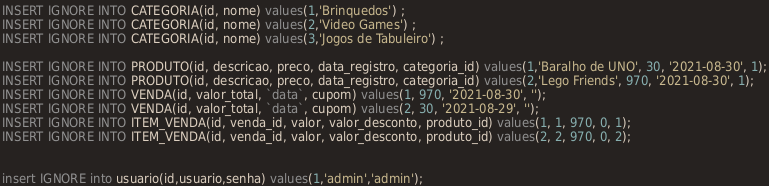<code> <loc_0><loc_0><loc_500><loc_500><_SQL_>INSERT IGNORE INTO CATEGORIA(id, nome) values(1,'Brinquedos') ;
INSERT IGNORE INTO CATEGORIA(id, nome) values(2,'Video Games') ;
INSERT IGNORE INTO CATEGORIA(id, nome) values(3,'Jogos de Tabuleiro') ;

INSERT IGNORE INTO PRODUTO(id, descricao, preco, data_registro, categoria_id) values(1,'Baralho de UNO', 30, '2021-08-30', 1);
INSERT IGNORE INTO PRODUTO(id, descricao, preco, data_registro, categoria_id) values(2,'Lego Friends', 970, '2021-08-30', 1);
INSERT IGNORE INTO VENDA(id, valor_total, `data`, cupom) values(1, 970, '2021-08-30', '');
INSERT IGNORE INTO VENDA(id, valor_total, `data`, cupom) values(2, 30, '2021-08-29', '');
INSERT IGNORE INTO ITEM_VENDA(id, venda_id, valor, valor_desconto, produto_id) values(1, 1, 970, 0, 1);
INSERT IGNORE INTO ITEM_VENDA(id, venda_id, valor, valor_desconto, produto_id) values(2, 2, 970, 0, 2);


insert IGNORE into usuario(id,usuario,senha) values(1,'admin','admin');</code> 